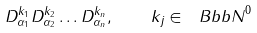Convert formula to latex. <formula><loc_0><loc_0><loc_500><loc_500>D _ { \alpha _ { 1 } } ^ { k _ { 1 } } D _ { \alpha _ { 2 } } ^ { k _ { 2 } } \dots D _ { \alpha _ { n } } ^ { k _ { n } } , \quad k _ { j } \in { \ B b b N } ^ { 0 }</formula> 